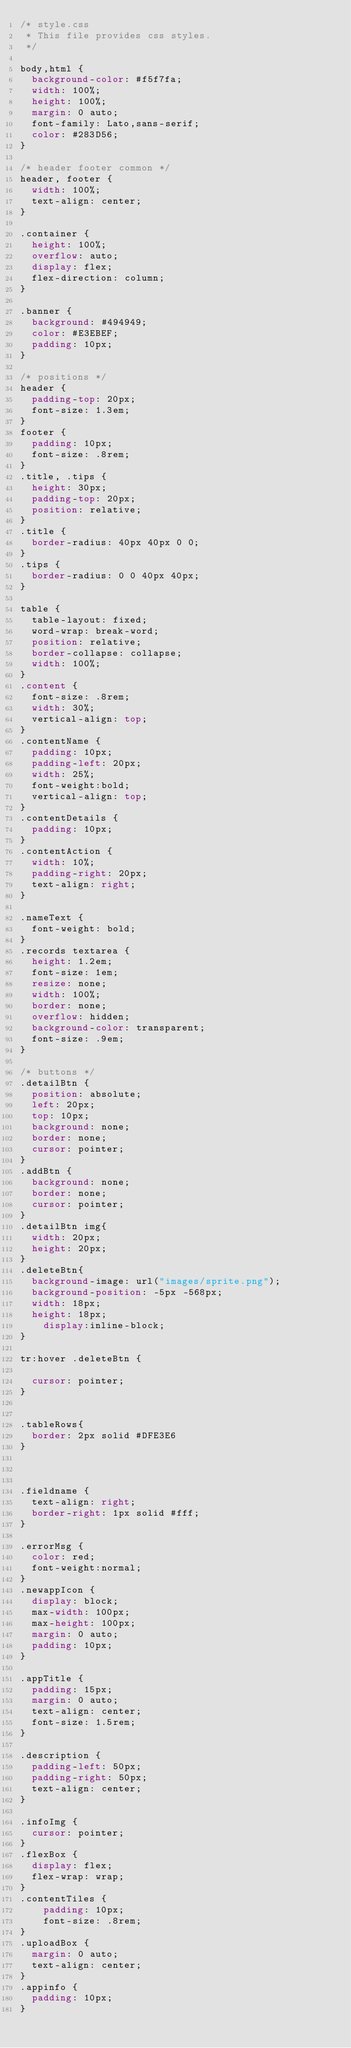<code> <loc_0><loc_0><loc_500><loc_500><_CSS_>/* style.css
 * This file provides css styles.
 */

body,html {
	background-color: #f5f7fa;
	width: 100%;
	height: 100%;
	margin: 0 auto;
	font-family: Lato,sans-serif;
	color: #283D56;
}

/* header footer common */
header, footer {
	width: 100%;
	text-align: center;
}

.container {
	height: 100%;
	overflow: auto;
	display: flex;
	flex-direction: column;
}

.banner {
	background: #494949;
	color: #E3EBEF;
	padding: 10px;
}

/* positions */
header {
	padding-top: 20px;
	font-size: 1.3em;
}
footer {
	padding: 10px;
	font-size: .8rem;
}
.title, .tips {
	height: 30px;
	padding-top: 20px;
	position: relative;
}
.title {
	border-radius: 40px 40px 0 0;
}
.tips {
	border-radius: 0 0 40px 40px;
}

table {
	table-layout: fixed;
	word-wrap: break-word;
	position: relative;
	border-collapse: collapse;
	width: 100%;
}
.content {
	font-size: .8rem;
	width: 30%;
	vertical-align: top;
}
.contentName {
	padding: 10px;
	padding-left: 20px;
	width: 25%;
	font-weight:bold;
	vertical-align: top;
}
.contentDetails {
	padding: 10px;
}
.contentAction {
	width: 10%;
	padding-right: 20px;
	text-align: right;
}

.nameText {
	font-weight: bold;
}
.records textarea {
	height: 1.2em;
	font-size: 1em;
	resize: none;
	width: 100%;
	border: none;
	overflow: hidden;
	background-color: transparent;
	font-size: .9em;
}

/* buttons */
.detailBtn {
	position: absolute;
	left: 20px;
	top: 10px;
	background: none;
	border: none;
	cursor: pointer;
}
.addBtn {
  background: none;
  border: none;
  cursor: pointer;
}
.detailBtn img{
	width: 20px;
	height: 20px;
}
.deleteBtn{
  background-image: url("images/sprite.png");
  background-position: -5px -568px;
  width: 18px;
  height: 18px;
    display:inline-block;
}

tr:hover .deleteBtn {

	cursor: pointer;
}


.tableRows{
	border: 2px solid #DFE3E6
}



.fieldname {
	text-align: right;
	border-right: 1px solid #fff;
}

.errorMsg {
	color: red;
	font-weight:normal;
}
.newappIcon {
  display: block;
  max-width: 100px;
  max-height: 100px;
  margin: 0 auto;
	padding: 10px;
}

.appTitle {
	padding: 15px;
  margin: 0 auto;
  text-align: center;
	font-size: 1.5rem;
}

.description {
  padding-left: 50px;
  padding-right: 50px;
  text-align: center;
}

.infoImg {
	cursor: pointer;
}
.flexBox {
	display: flex;
	flex-wrap: wrap;
}
.contentTiles {
		padding: 10px;
		font-size: .8rem;
}
.uploadBox {
  margin: 0 auto;
  text-align: center;
}
.appinfo {
	padding: 10px;
}
</code> 